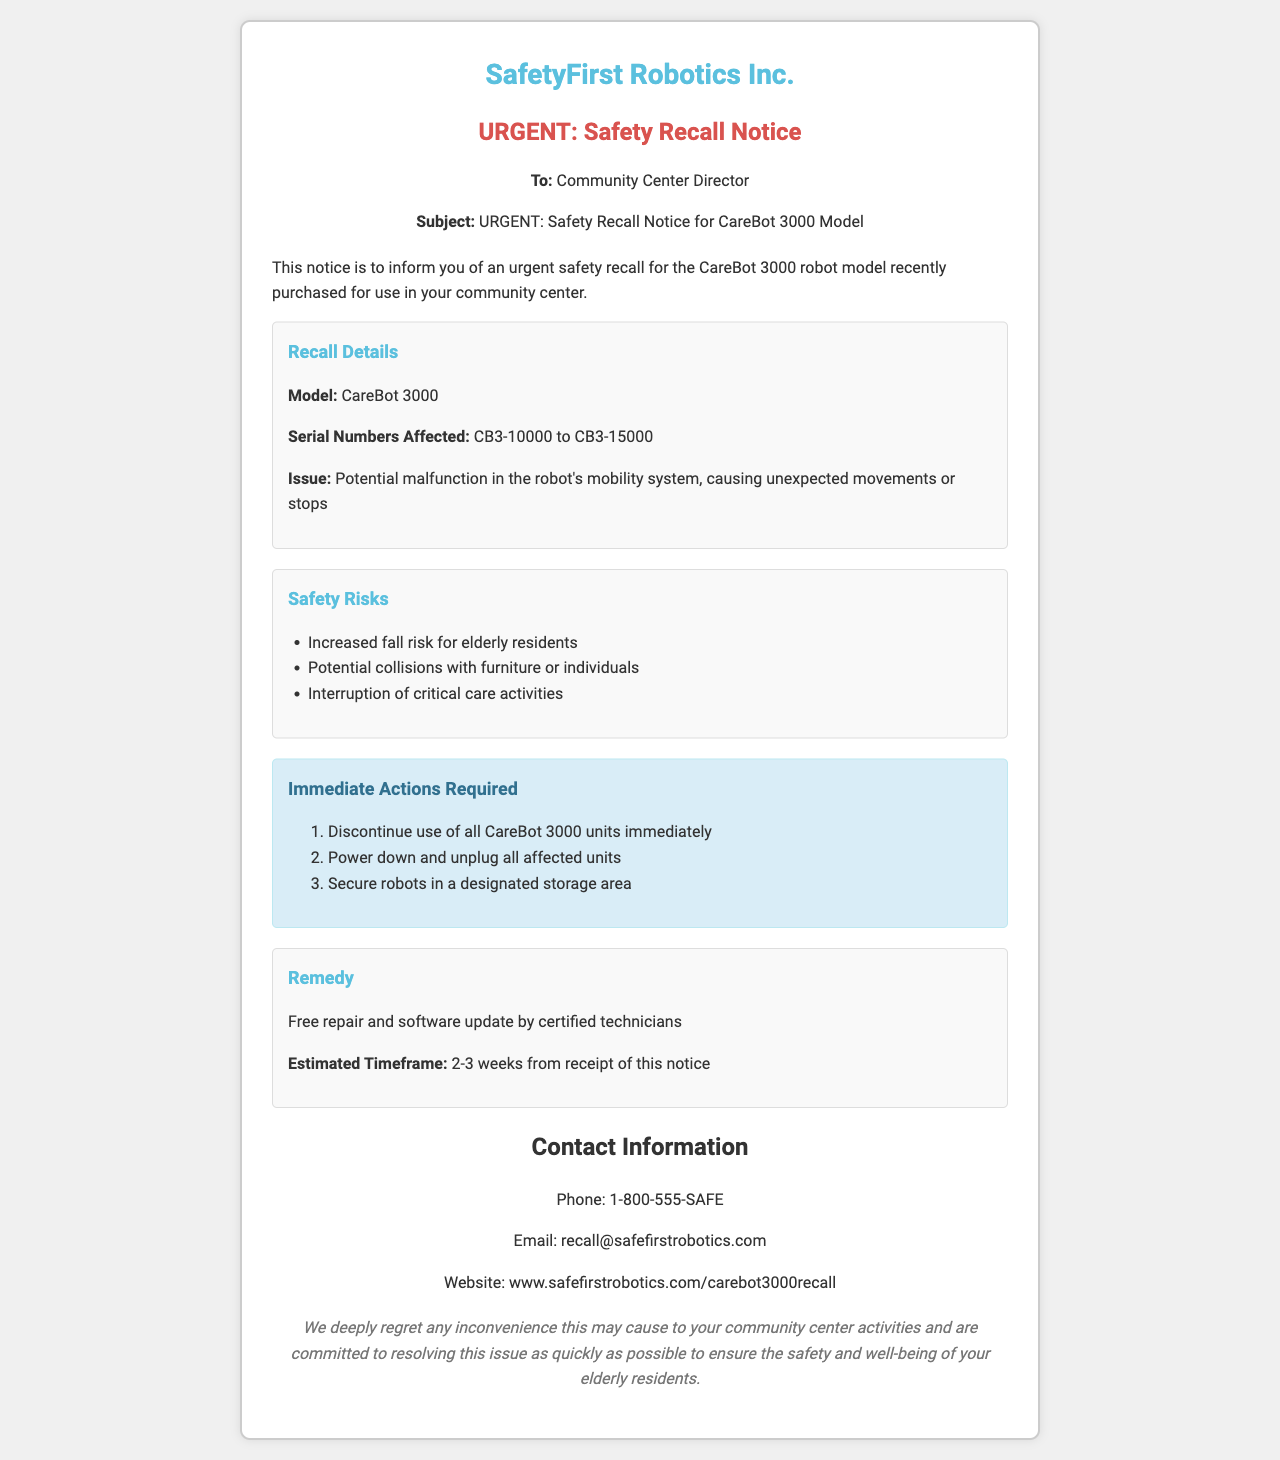What is the model number of the recalled robot? The model number is specifically mentioned for the robot in the document.
Answer: CareBot 3000 What are the affected serial numbers? The document lists the range of serial numbers that are affected by the recall.
Answer: CB3-10000 to CB3-15000 What is the main issue with the CareBot 3000? The document outlines a specific malfunction related to the robot's mobility system.
Answer: Potential malfunction in the robot's mobility system What is one safety risk mentioned in the document? The document lists various safety risks, requiring retrieval of specific information.
Answer: Increased fall risk for elderly residents What is the timeframe estimated for repairs? The document provides an estimated timeframe for repair after receipt of notice.
Answer: 2-3 weeks What is the first immediate action required? The document lists immediate actions in an ordered format, allowing for identification of the first action.
Answer: Discontinue use of all CareBot 3000 units immediately What type of remedy is offered for the recall? The document specifies what will be provided as a remedy for the affected robots.
Answer: Free repair and software update What is the contact phone number for the recall? The document provides a specific contact phone number for further inquiries.
Answer: 1-800-555-SAFE What organization issued this recall notice? The document includes the name of the organization responsible for the notice.
Answer: SafetyFirst Robotics Inc 